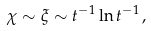<formula> <loc_0><loc_0><loc_500><loc_500>\chi \sim \xi \sim t ^ { - 1 } \ln t ^ { - 1 } \, ,</formula> 